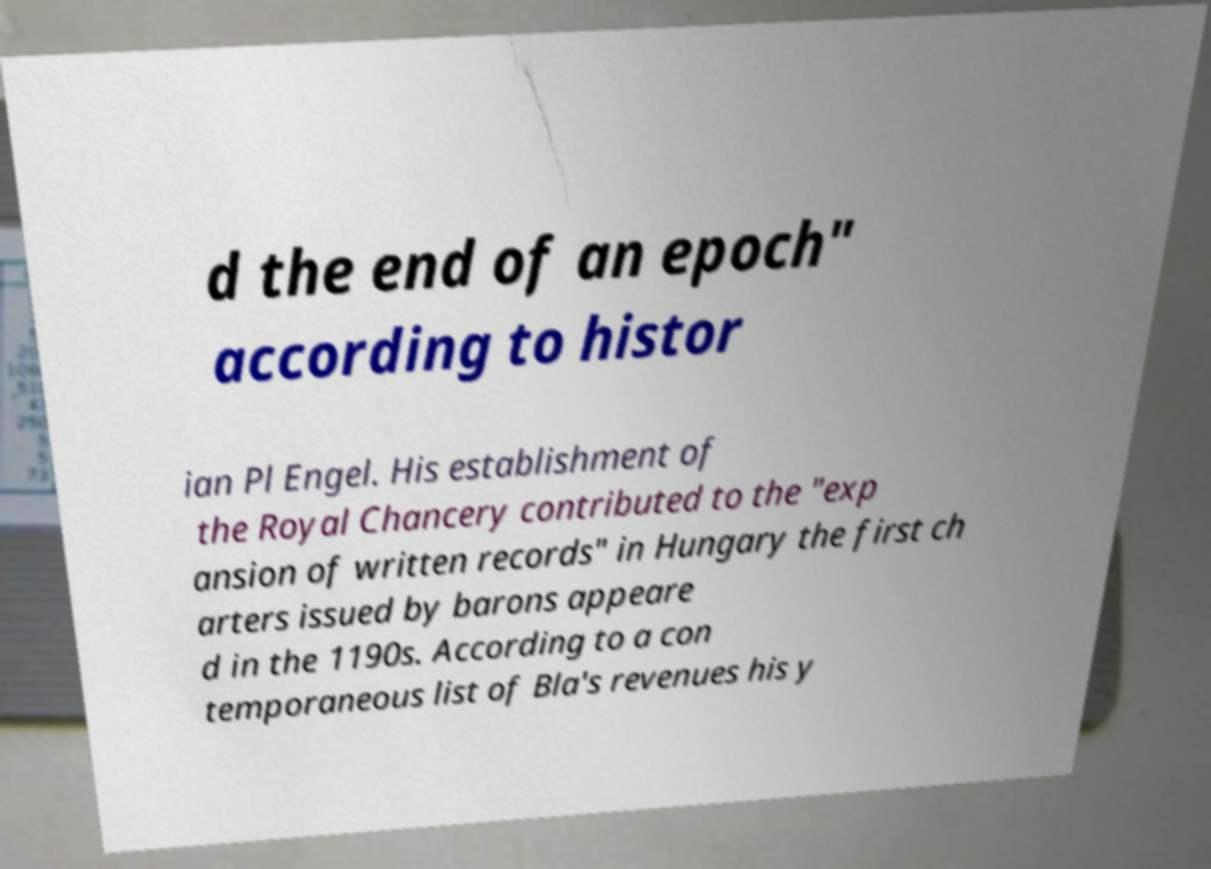Could you assist in decoding the text presented in this image and type it out clearly? d the end of an epoch" according to histor ian Pl Engel. His establishment of the Royal Chancery contributed to the "exp ansion of written records" in Hungary the first ch arters issued by barons appeare d in the 1190s. According to a con temporaneous list of Bla's revenues his y 